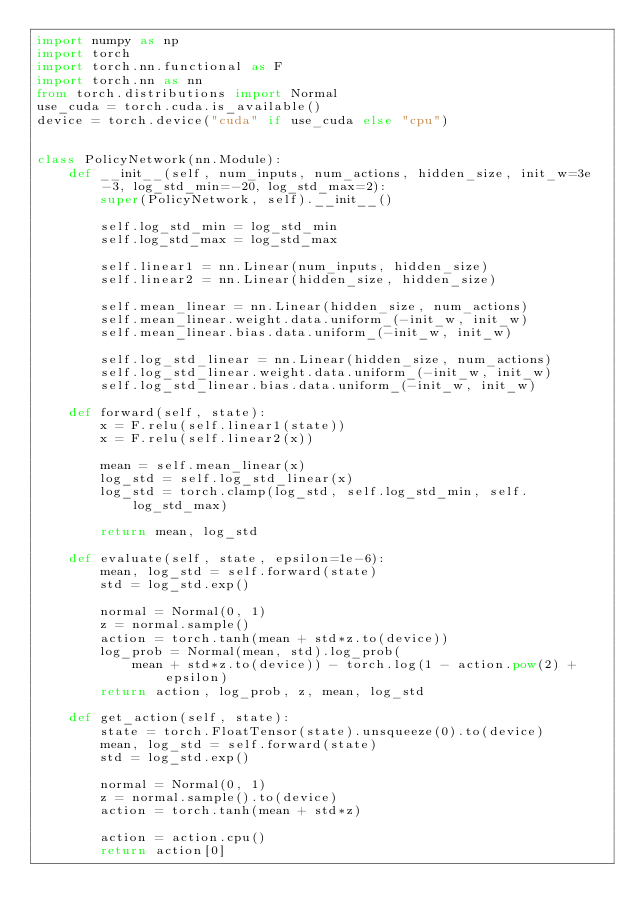<code> <loc_0><loc_0><loc_500><loc_500><_Python_>import numpy as np
import torch
import torch.nn.functional as F
import torch.nn as nn
from torch.distributions import Normal
use_cuda = torch.cuda.is_available()
device = torch.device("cuda" if use_cuda else "cpu")


class PolicyNetwork(nn.Module):
    def __init__(self, num_inputs, num_actions, hidden_size, init_w=3e-3, log_std_min=-20, log_std_max=2):
        super(PolicyNetwork, self).__init__()

        self.log_std_min = log_std_min
        self.log_std_max = log_std_max

        self.linear1 = nn.Linear(num_inputs, hidden_size)
        self.linear2 = nn.Linear(hidden_size, hidden_size)

        self.mean_linear = nn.Linear(hidden_size, num_actions)
        self.mean_linear.weight.data.uniform_(-init_w, init_w)
        self.mean_linear.bias.data.uniform_(-init_w, init_w)

        self.log_std_linear = nn.Linear(hidden_size, num_actions)
        self.log_std_linear.weight.data.uniform_(-init_w, init_w)
        self.log_std_linear.bias.data.uniform_(-init_w, init_w)

    def forward(self, state):
        x = F.relu(self.linear1(state))
        x = F.relu(self.linear2(x))

        mean = self.mean_linear(x)
        log_std = self.log_std_linear(x)
        log_std = torch.clamp(log_std, self.log_std_min, self.log_std_max)

        return mean, log_std

    def evaluate(self, state, epsilon=1e-6):
        mean, log_std = self.forward(state)
        std = log_std.exp()

        normal = Normal(0, 1)
        z = normal.sample()
        action = torch.tanh(mean + std*z.to(device))
        log_prob = Normal(mean, std).log_prob(
            mean + std*z.to(device)) - torch.log(1 - action.pow(2) + epsilon)
        return action, log_prob, z, mean, log_std

    def get_action(self, state):
        state = torch.FloatTensor(state).unsqueeze(0).to(device)
        mean, log_std = self.forward(state)
        std = log_std.exp()

        normal = Normal(0, 1)
        z = normal.sample().to(device)
        action = torch.tanh(mean + std*z)

        action = action.cpu()
        return action[0]
</code> 